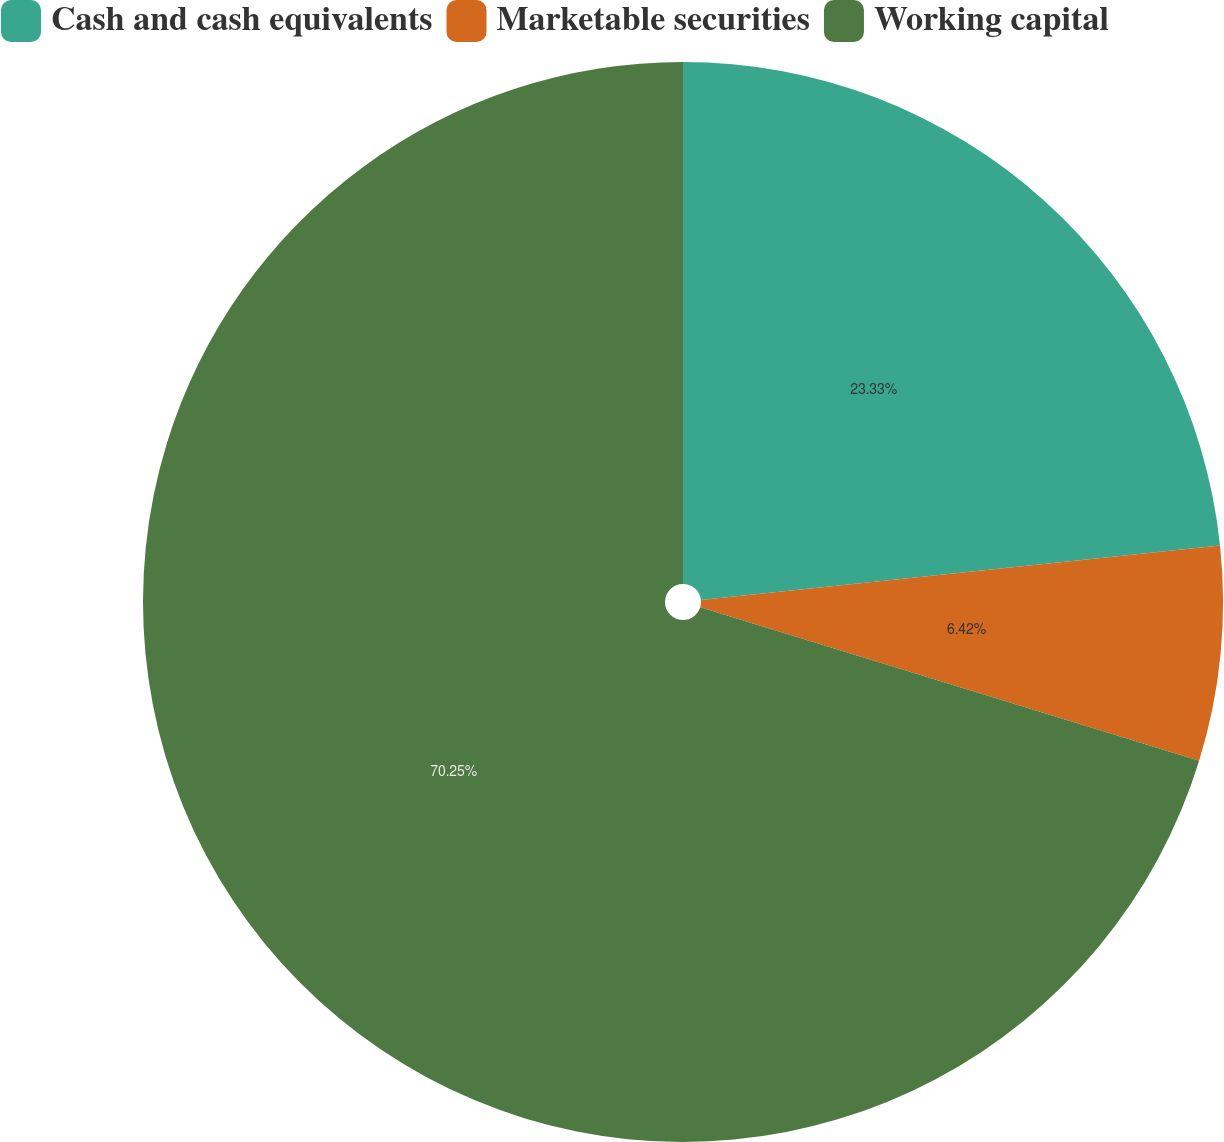Convert chart to OTSL. <chart><loc_0><loc_0><loc_500><loc_500><pie_chart><fcel>Cash and cash equivalents<fcel>Marketable securities<fcel>Working capital<nl><fcel>23.33%<fcel>6.42%<fcel>70.25%<nl></chart> 